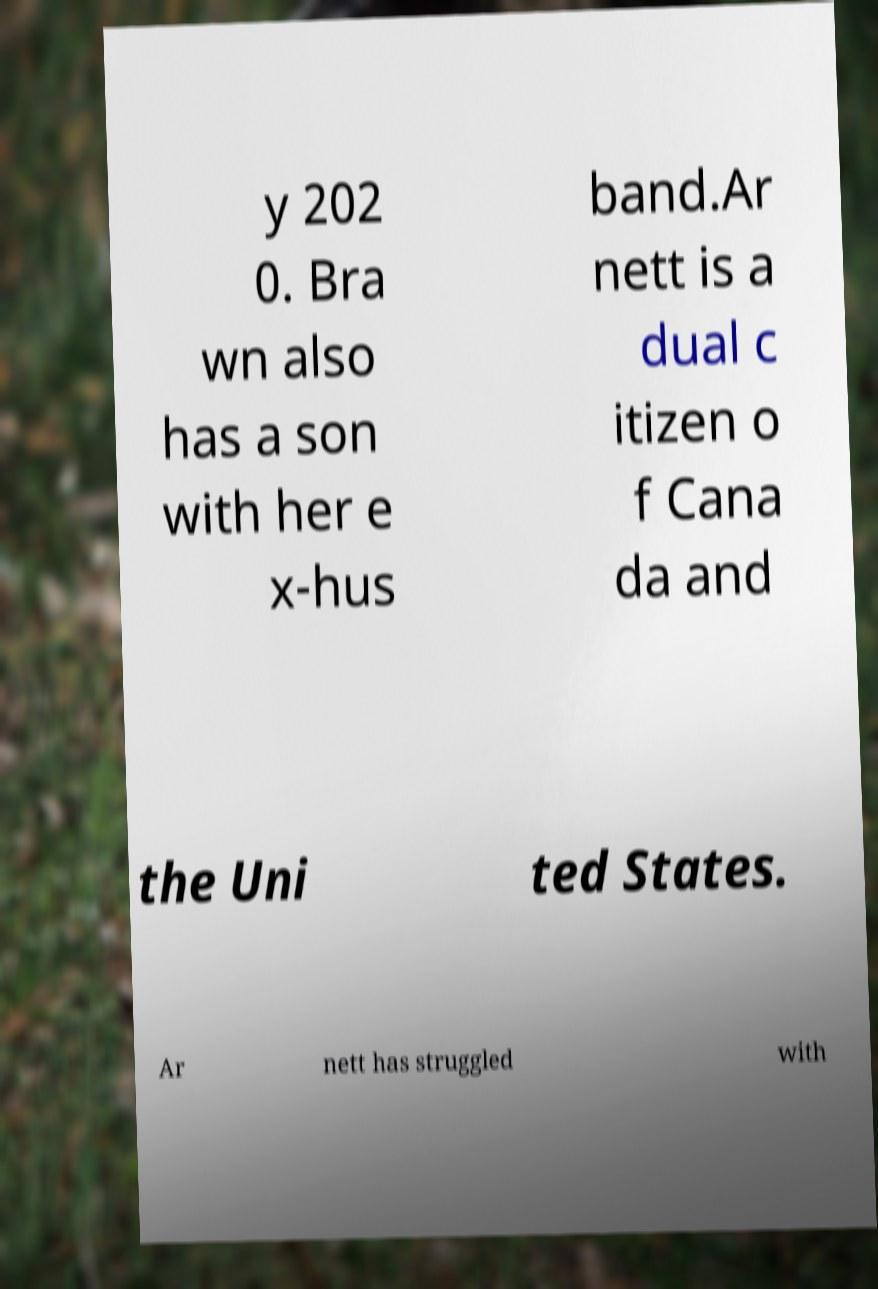Can you read and provide the text displayed in the image?This photo seems to have some interesting text. Can you extract and type it out for me? y 202 0. Bra wn also has a son with her e x-hus band.Ar nett is a dual c itizen o f Cana da and the Uni ted States. Ar nett has struggled with 